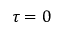<formula> <loc_0><loc_0><loc_500><loc_500>\tau = 0</formula> 